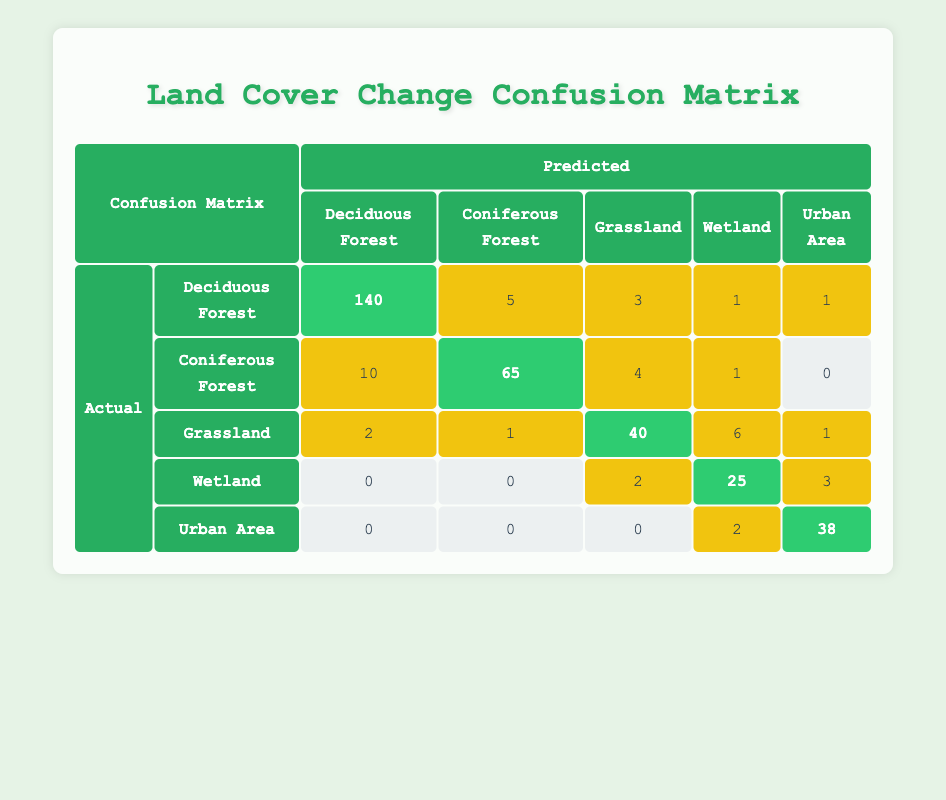What is the predicted count for Deciduous Forest classified as Deciduous Forest? The table shows that the predicted count for Deciduous Forest correctly classified as Deciduous Forest is in the cell where the actual class and predicted class both are Deciduous Forest, which is 140.
Answer: 140 How many instances were incorrectly classified as Coniferous Forest from Grassland? To find this, look at the Grassland row and locate the Coniferous Forest column. The value in that cell indicates the number of times Grassland was incorrectly classified as Coniferous Forest, which is 1.
Answer: 1 Is there any predicted classification for Deciduous Forest in Urban Area? To answer this question, check the Urban Area row and find the Deciduous Forest column. The value in that cell is 0, indicating that there are no instances of Deciduous Forest incorrectly classified as Urban Area.
Answer: No What is the total number of predicted instances for Wetland? To get the total predicted instances for Wetland, we sum the values in the Wetland column: 1 + 1 + 6 + 25 + 3 = 36.
Answer: 36 How many total instances were misclassified across all classes? To find the total misclassifications, we need to check all cells that are not on the diagonal and add those values together: 5 + 3 + 1 + 1 + 10 + 4 + 1 + 2 + 0 + 0 + 2 + 3 = 28.
Answer: 28 What proportion of Coniferous Forest was correctly classified? The correctly classified instances for Coniferous Forest, found in the Coniferous Forest row and column, is 65. The total for that row (the actual instances) is 80. The proportion is thus 65/80 = 0.8125.
Answer: 0.8125 What is the average number of misclassifications for Urban Area? To calculate the average misclassifications for Urban Area, observe all the other classes in the Urban Area row: 0 + 0 + 0 + 2 = 2. Since there are 4 misclassified instances, we divide by 4 which gives 2/4 = 0.5.
Answer: 0.5 How many Grassland instances were predicted correctly? The correctly predicted Grassland instances can be found in the Grassland row, specifically in the Grassland column: the value is 40.
Answer: 40 How many total instances were predicted as Urban Area? To find this, we sum the values in the Urban Area column: 1 + 0 + 1 + 3 + 38 = 43.
Answer: 43 